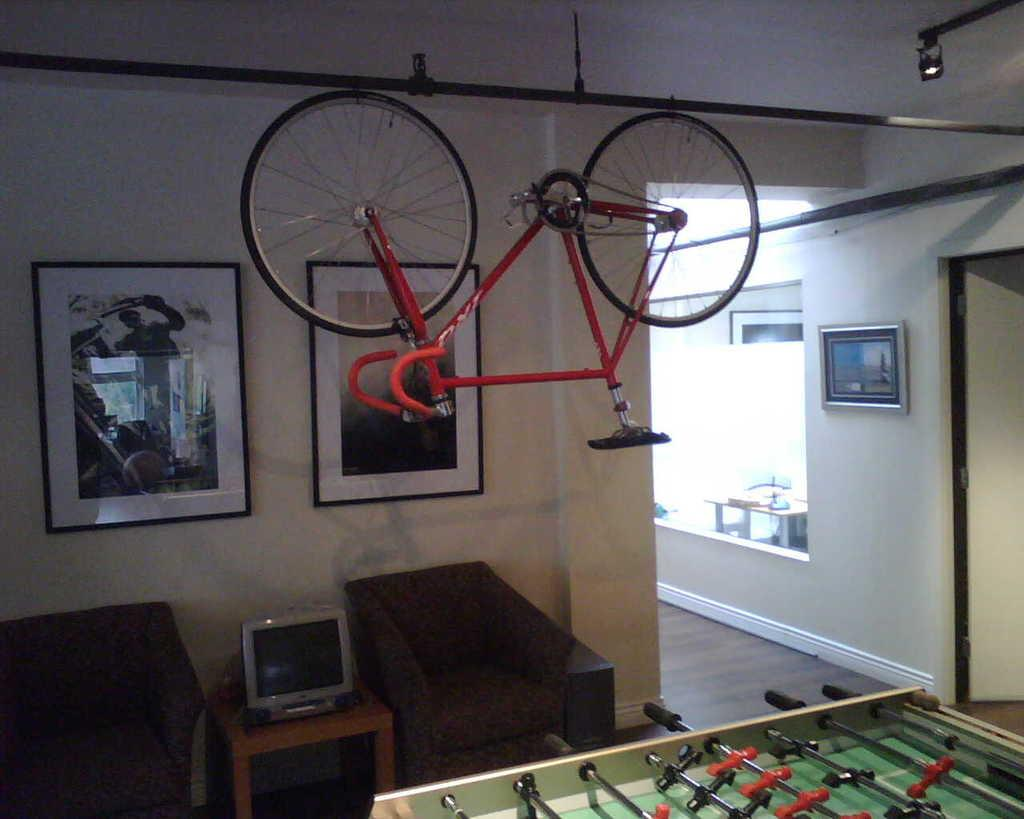What is hanging from a rope in the image? There is a bi-cycle hanging from a rope in the image. What is present on a table in the image? There is a desktop on a table in the image. How many couches are in the image? There are two couches in the image. What can be seen in the background of the image? There is a wall in the background of the image, and two frames are attached to it. Are there any bears visible in the image? No, there are no bears present in the image. What type of beetle can be seen crawling on the desktop in the image? There is no beetle present on the desktop or anywhere else in the image. 